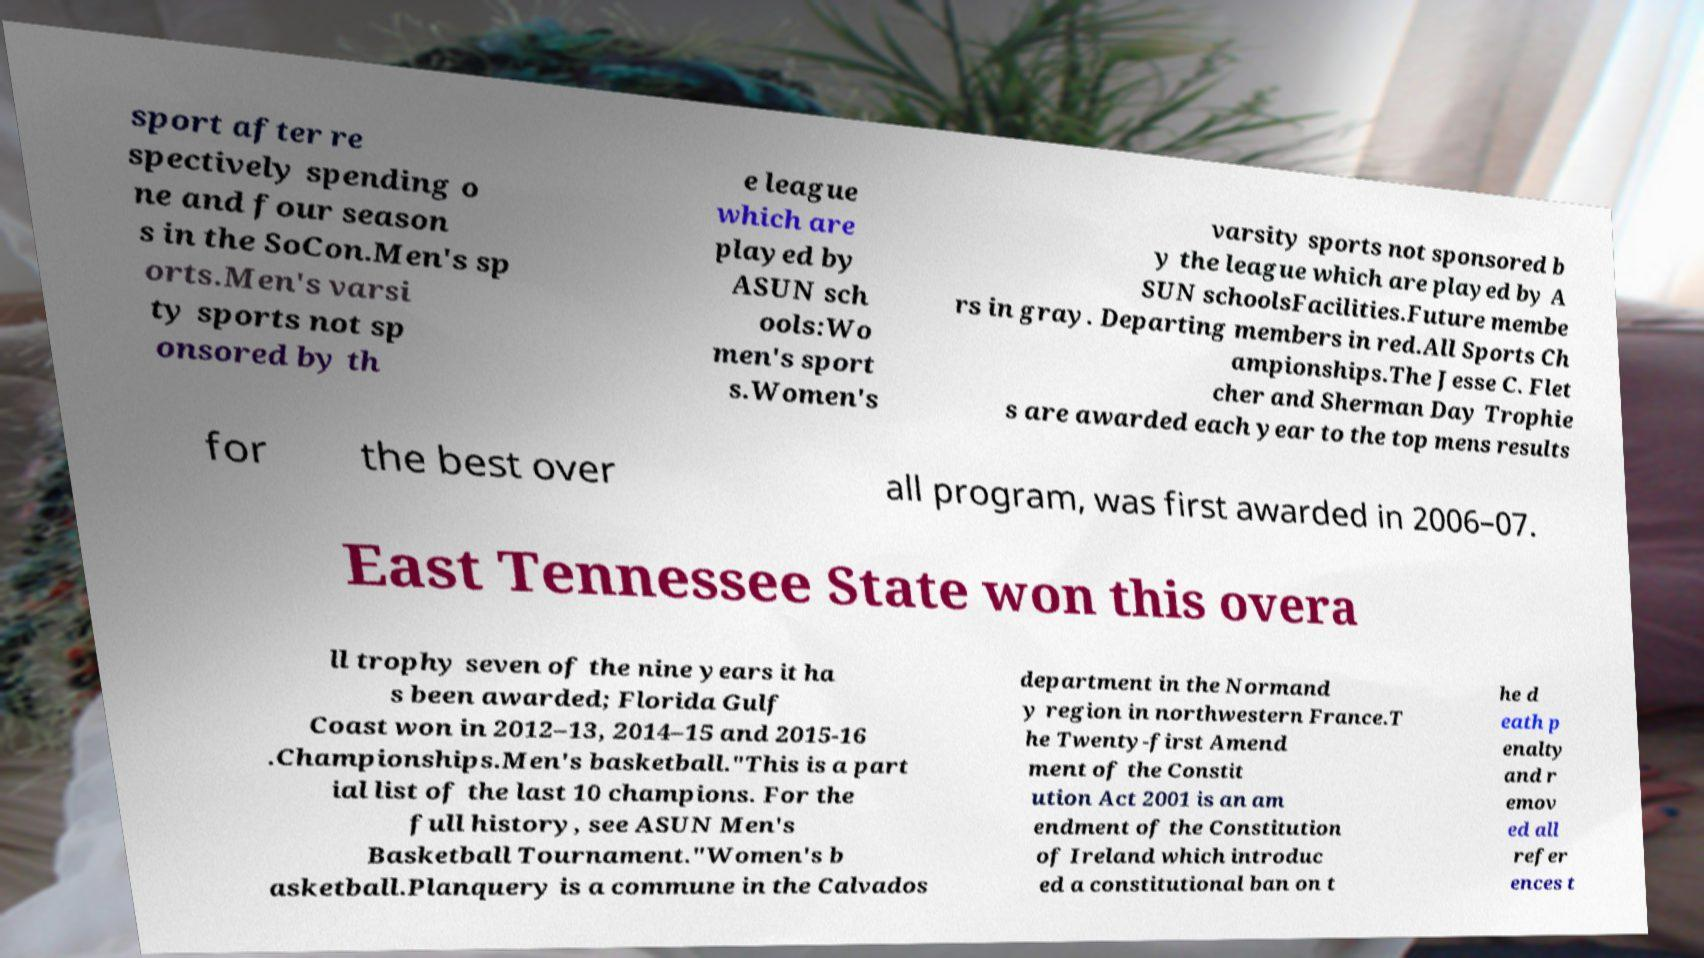For documentation purposes, I need the text within this image transcribed. Could you provide that? sport after re spectively spending o ne and four season s in the SoCon.Men's sp orts.Men's varsi ty sports not sp onsored by th e league which are played by ASUN sch ools:Wo men's sport s.Women's varsity sports not sponsored b y the league which are played by A SUN schoolsFacilities.Future membe rs in gray. Departing members in red.All Sports Ch ampionships.The Jesse C. Flet cher and Sherman Day Trophie s are awarded each year to the top mens results for the best over all program, was first awarded in 2006–07. East Tennessee State won this overa ll trophy seven of the nine years it ha s been awarded; Florida Gulf Coast won in 2012–13, 2014–15 and 2015-16 .Championships.Men's basketball."This is a part ial list of the last 10 champions. For the full history, see ASUN Men's Basketball Tournament."Women's b asketball.Planquery is a commune in the Calvados department in the Normand y region in northwestern France.T he Twenty-first Amend ment of the Constit ution Act 2001 is an am endment of the Constitution of Ireland which introduc ed a constitutional ban on t he d eath p enalty and r emov ed all refer ences t 